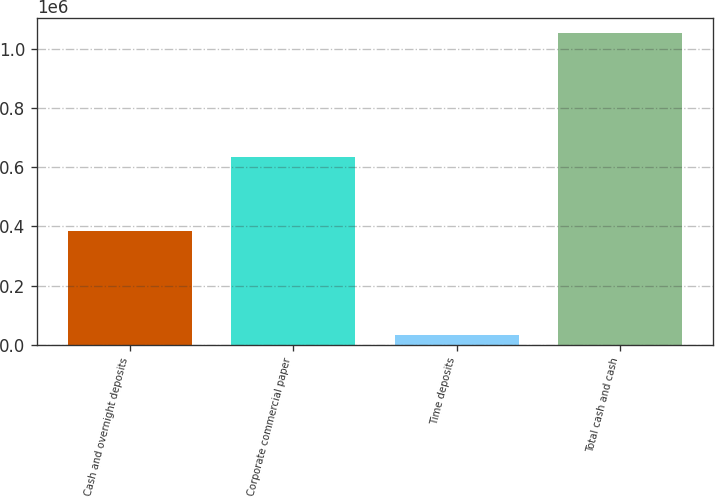Convert chart to OTSL. <chart><loc_0><loc_0><loc_500><loc_500><bar_chart><fcel>Cash and overnight deposits<fcel>Corporate commercial paper<fcel>Time deposits<fcel>Total cash and cash<nl><fcel>383021<fcel>635345<fcel>32733<fcel>1.0511e+06<nl></chart> 